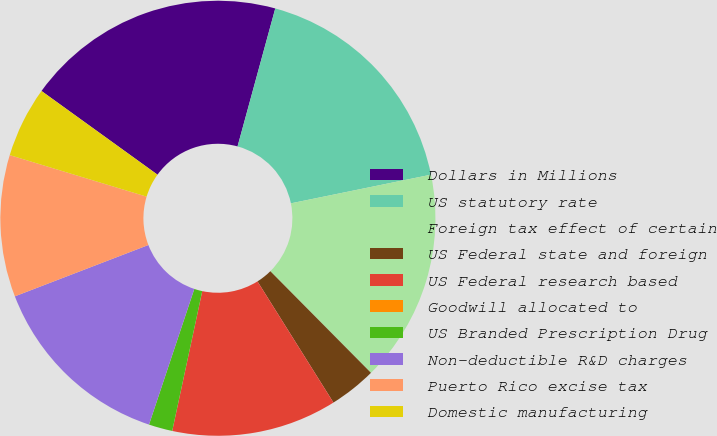Convert chart. <chart><loc_0><loc_0><loc_500><loc_500><pie_chart><fcel>Dollars in Millions<fcel>US statutory rate<fcel>Foreign tax effect of certain<fcel>US Federal state and foreign<fcel>US Federal research based<fcel>Goodwill allocated to<fcel>US Branded Prescription Drug<fcel>Non-deductible R&D charges<fcel>Puerto Rico excise tax<fcel>Domestic manufacturing<nl><fcel>19.3%<fcel>17.54%<fcel>15.79%<fcel>3.51%<fcel>12.28%<fcel>0.0%<fcel>1.76%<fcel>14.03%<fcel>10.53%<fcel>5.26%<nl></chart> 